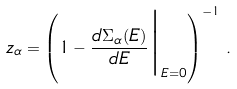Convert formula to latex. <formula><loc_0><loc_0><loc_500><loc_500>z _ { \alpha } = \left ( 1 - \frac { d \Sigma _ { \alpha } ( E ) } { d E } \Big | _ { E = 0 } \right ) ^ { - 1 } \, .</formula> 